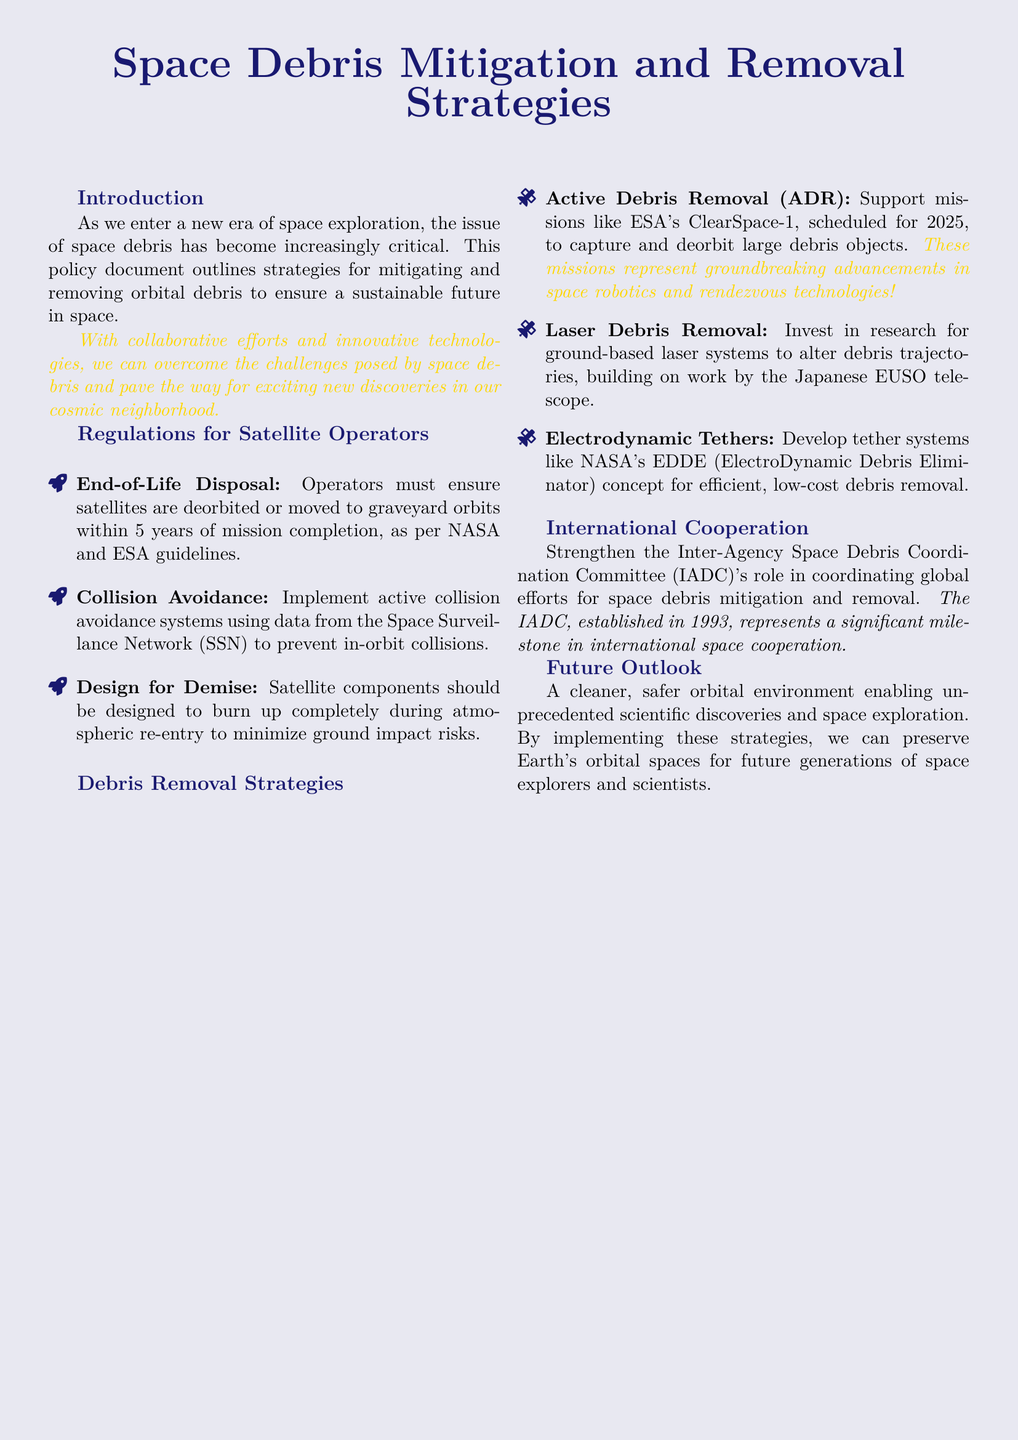What is the title of the policy document? The title of the policy document is prominently displayed at the beginning, indicating the main focus on space debris.
Answer: Space Debris Mitigation and Removal Strategies What is the deadline for satellite end-of-life disposal? The document states specific time frames for disposing of satellites, which is within 5 years.
Answer: 5 years Which mission is scheduled for 2025? The text includes a mention of specific missions aimed at debris removal and indicates ESA's ClearSpace-1 as an upcoming mission.
Answer: ESA's ClearSpace-1 What technology is involved in the Electrodynamic Debris Eliminator concept? The document describes a specific innovative technology for debris removal that NASA is developing.
Answer: Tether systems What organization coordinates efforts for space debris mitigation? The document highlights a particular organization that plays a crucial role in coordinating international debris efforts.
Answer: Inter-Agency Space Debris Coordination Committee What is one strategy for collision avoidance mentioned? The document specifies that operators must implement specific systems to prevent collisions in orbit.
Answer: Active collision avoidance systems What does "Design for Demise" refer to? This term is outlined in the document as a requirement for how satellite components should be engineered during re-entry.
Answer: Burn up completely during atmospheric re-entry What is the significance of the year 1993 in relation to space debris? An important milestone related to international cooperation in space is noted, with this year marking the establishment of a key committee.
Answer: Established in 1993 What type of removal strategy involves altering debris trajectories? The text includes a cutting-edge approach that uses a specific system to manage space debris, highlighting its innovative nature.
Answer: Laser Debris Removal 